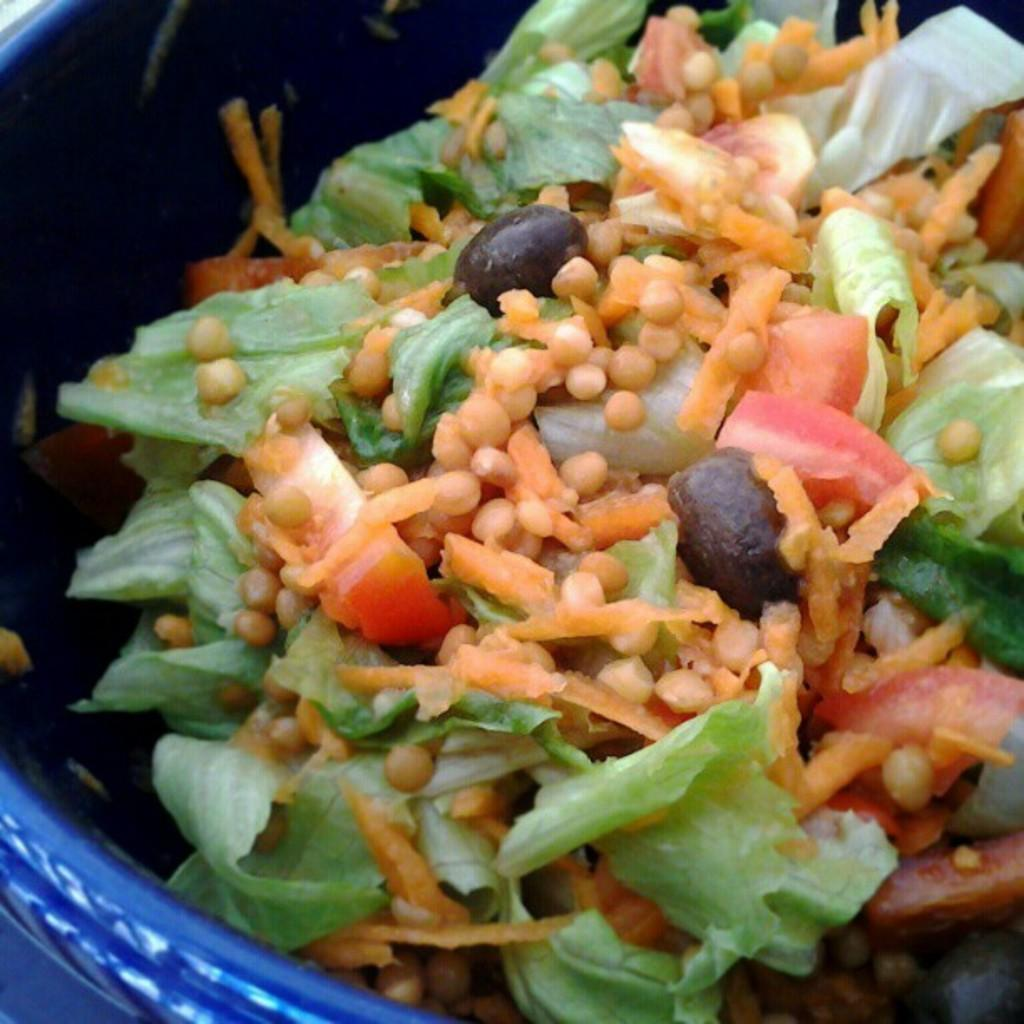What is in the bowl that is visible in the image? There is a salad in a bowl in the image. Where is the bowl located in the image? The bowl is placed on a table. What type of airplane can be seen flying over the salad in the image? There is no airplane visible in the image; it only features a bowl of salad on a table. 